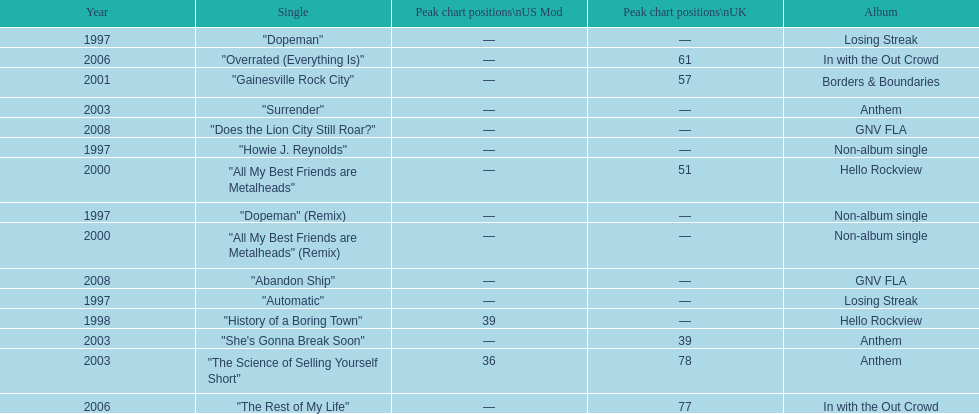How long was it between losing streak almbum and gnv fla in years. 11. 